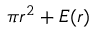Convert formula to latex. <formula><loc_0><loc_0><loc_500><loc_500>\, \pi r ^ { 2 } + E ( r )</formula> 